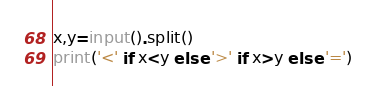<code> <loc_0><loc_0><loc_500><loc_500><_Python_>x,y=input().split()
print('<' if x<y else '>' if x>y else '=')</code> 